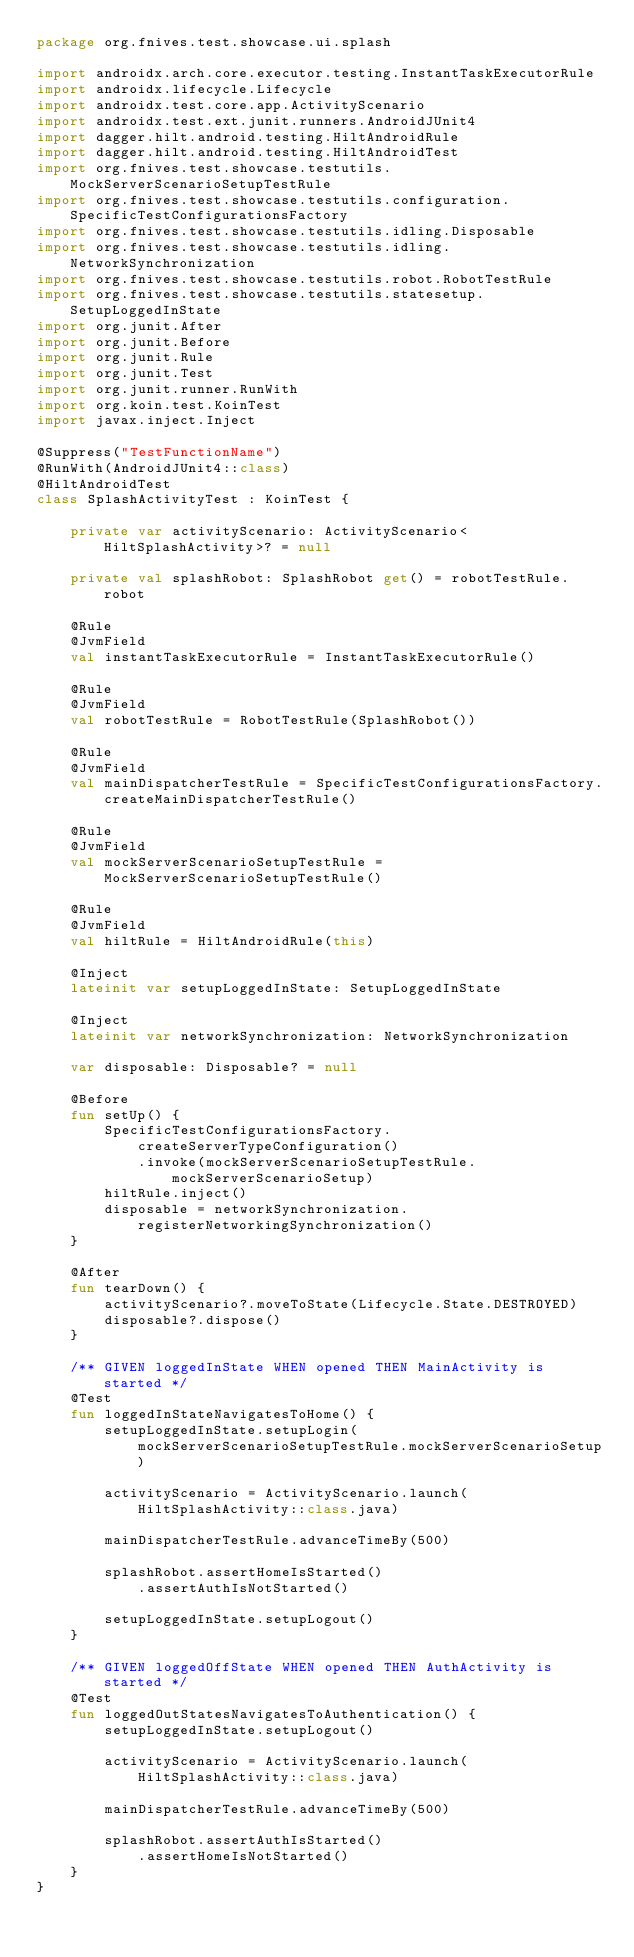<code> <loc_0><loc_0><loc_500><loc_500><_Kotlin_>package org.fnives.test.showcase.ui.splash

import androidx.arch.core.executor.testing.InstantTaskExecutorRule
import androidx.lifecycle.Lifecycle
import androidx.test.core.app.ActivityScenario
import androidx.test.ext.junit.runners.AndroidJUnit4
import dagger.hilt.android.testing.HiltAndroidRule
import dagger.hilt.android.testing.HiltAndroidTest
import org.fnives.test.showcase.testutils.MockServerScenarioSetupTestRule
import org.fnives.test.showcase.testutils.configuration.SpecificTestConfigurationsFactory
import org.fnives.test.showcase.testutils.idling.Disposable
import org.fnives.test.showcase.testutils.idling.NetworkSynchronization
import org.fnives.test.showcase.testutils.robot.RobotTestRule
import org.fnives.test.showcase.testutils.statesetup.SetupLoggedInState
import org.junit.After
import org.junit.Before
import org.junit.Rule
import org.junit.Test
import org.junit.runner.RunWith
import org.koin.test.KoinTest
import javax.inject.Inject

@Suppress("TestFunctionName")
@RunWith(AndroidJUnit4::class)
@HiltAndroidTest
class SplashActivityTest : KoinTest {

    private var activityScenario: ActivityScenario<HiltSplashActivity>? = null

    private val splashRobot: SplashRobot get() = robotTestRule.robot

    @Rule
    @JvmField
    val instantTaskExecutorRule = InstantTaskExecutorRule()

    @Rule
    @JvmField
    val robotTestRule = RobotTestRule(SplashRobot())

    @Rule
    @JvmField
    val mainDispatcherTestRule = SpecificTestConfigurationsFactory.createMainDispatcherTestRule()

    @Rule
    @JvmField
    val mockServerScenarioSetupTestRule = MockServerScenarioSetupTestRule()

    @Rule
    @JvmField
    val hiltRule = HiltAndroidRule(this)

    @Inject
    lateinit var setupLoggedInState: SetupLoggedInState

    @Inject
    lateinit var networkSynchronization: NetworkSynchronization

    var disposable: Disposable? = null

    @Before
    fun setUp() {
        SpecificTestConfigurationsFactory.createServerTypeConfiguration()
            .invoke(mockServerScenarioSetupTestRule.mockServerScenarioSetup)
        hiltRule.inject()
        disposable = networkSynchronization.registerNetworkingSynchronization()
    }

    @After
    fun tearDown() {
        activityScenario?.moveToState(Lifecycle.State.DESTROYED)
        disposable?.dispose()
    }

    /** GIVEN loggedInState WHEN opened THEN MainActivity is started */
    @Test
    fun loggedInStateNavigatesToHome() {
        setupLoggedInState.setupLogin(mockServerScenarioSetupTestRule.mockServerScenarioSetup)

        activityScenario = ActivityScenario.launch(HiltSplashActivity::class.java)

        mainDispatcherTestRule.advanceTimeBy(500)

        splashRobot.assertHomeIsStarted()
            .assertAuthIsNotStarted()

        setupLoggedInState.setupLogout()
    }

    /** GIVEN loggedOffState WHEN opened THEN AuthActivity is started */
    @Test
    fun loggedOutStatesNavigatesToAuthentication() {
        setupLoggedInState.setupLogout()

        activityScenario = ActivityScenario.launch(HiltSplashActivity::class.java)

        mainDispatcherTestRule.advanceTimeBy(500)

        splashRobot.assertAuthIsStarted()
            .assertHomeIsNotStarted()
    }
}
</code> 